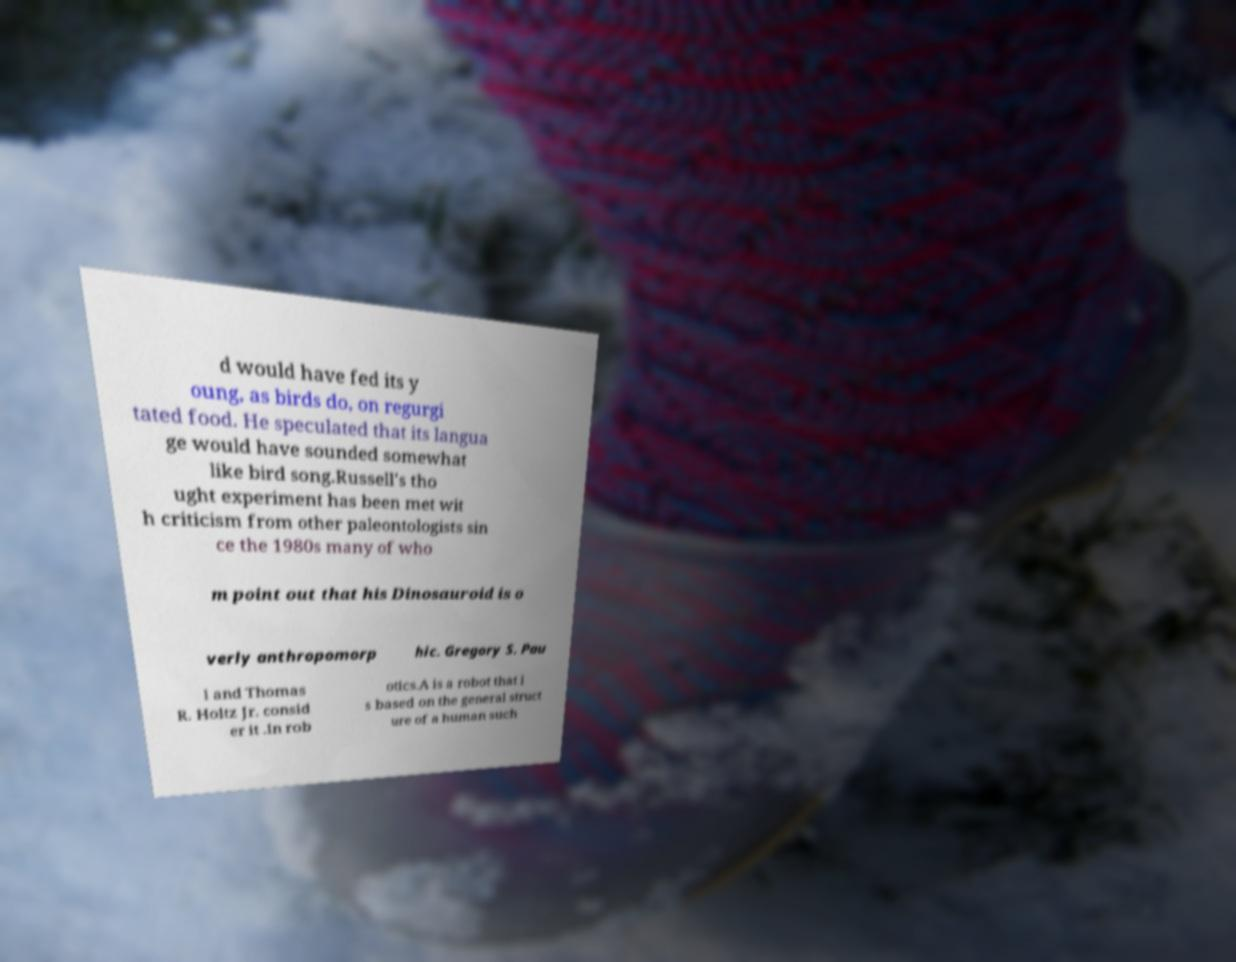Could you assist in decoding the text presented in this image and type it out clearly? d would have fed its y oung, as birds do, on regurgi tated food. He speculated that its langua ge would have sounded somewhat like bird song.Russell's tho ught experiment has been met wit h criticism from other paleontologists sin ce the 1980s many of who m point out that his Dinosauroid is o verly anthropomorp hic. Gregory S. Pau l and Thomas R. Holtz Jr. consid er it .In rob otics.A is a robot that i s based on the general struct ure of a human such 